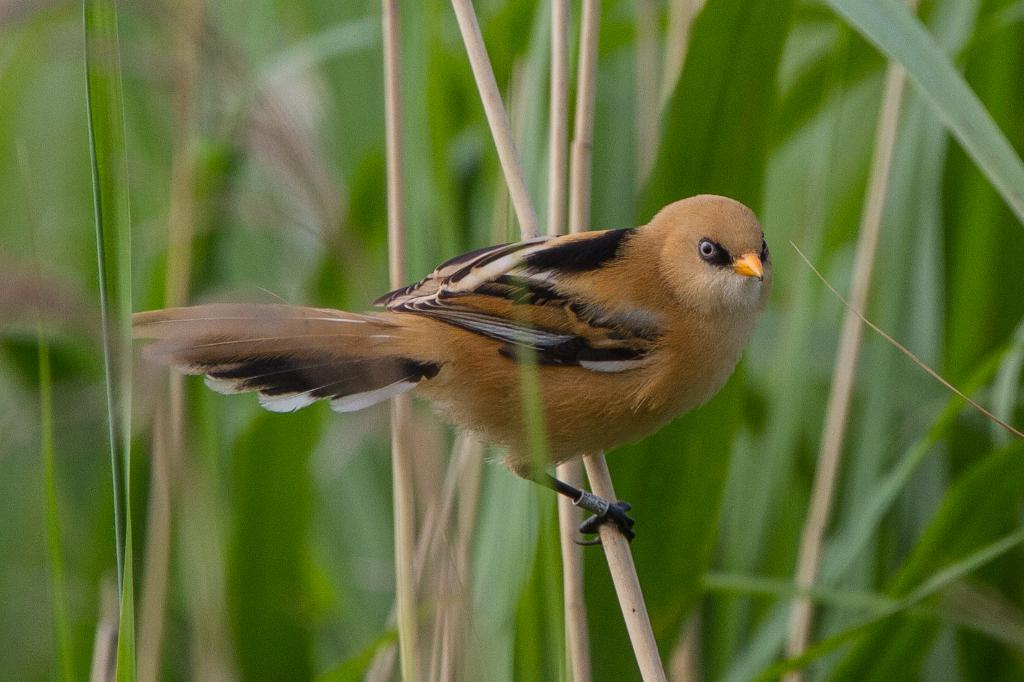What type of animal is in the image? There is a bird in the image. What is the bird standing on? The bird is standing on a wooden stick. What can be seen in the background of the image? There are trees in the background of the image. How would you describe the background of the image? The background appears blurry. What type of glue is being used to hold the bird in the image? There is no glue present in the image; the bird is standing on a wooden stick. How does the bird in the image compare to other birds in terms of size? The provided facts do not include any information about the size of the bird or any other birds, so it is impossible to make a comparison. 